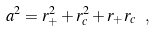Convert formula to latex. <formula><loc_0><loc_0><loc_500><loc_500>a ^ { 2 } = r _ { + } ^ { 2 } + r _ { c } ^ { 2 } + r _ { + } r _ { c } \ ,</formula> 